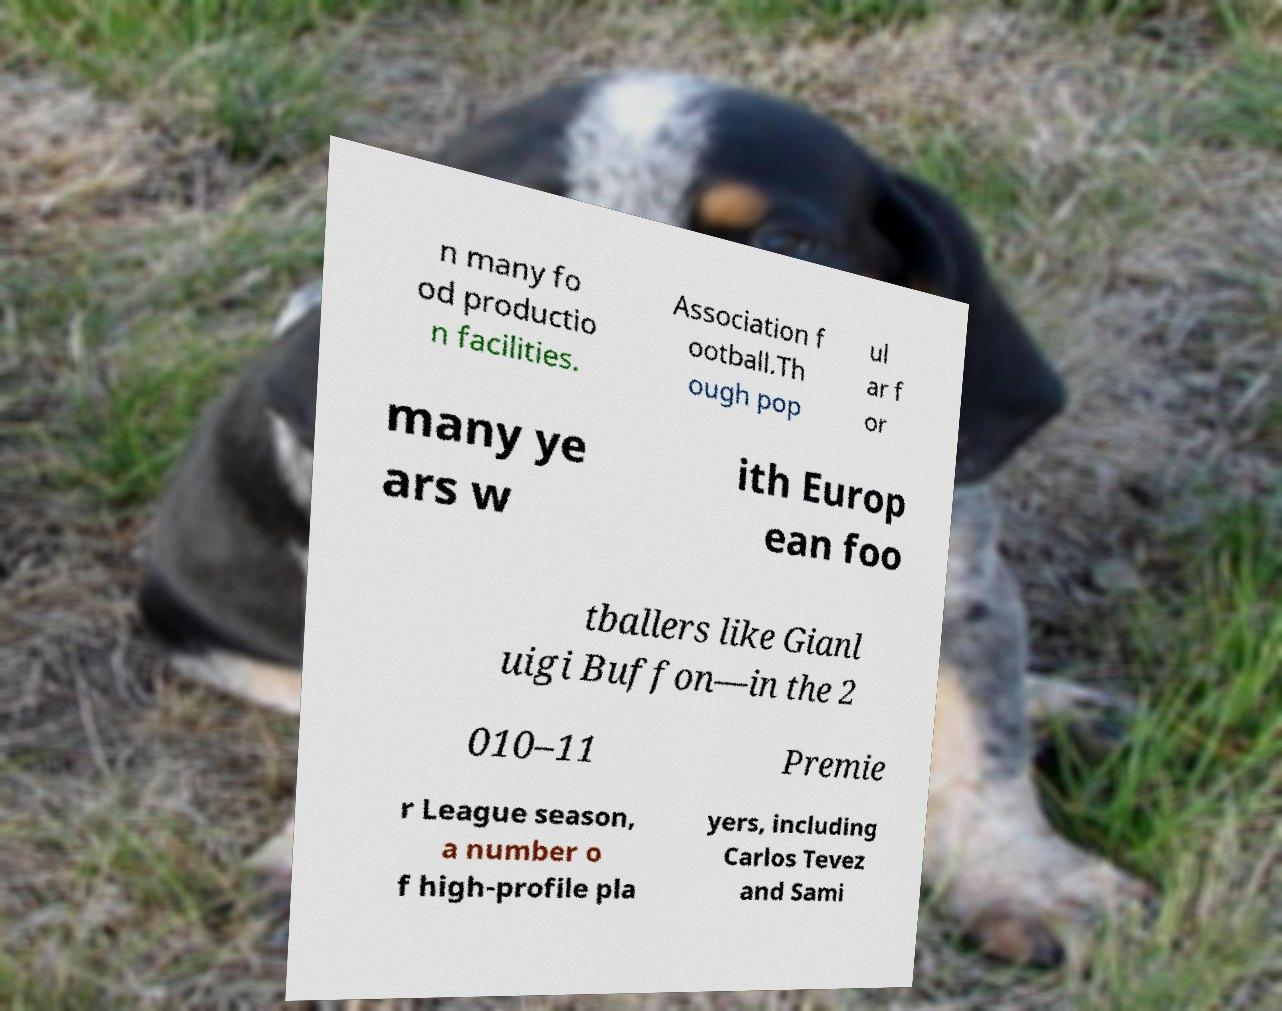There's text embedded in this image that I need extracted. Can you transcribe it verbatim? n many fo od productio n facilities. Association f ootball.Th ough pop ul ar f or many ye ars w ith Europ ean foo tballers like Gianl uigi Buffon—in the 2 010–11 Premie r League season, a number o f high-profile pla yers, including Carlos Tevez and Sami 